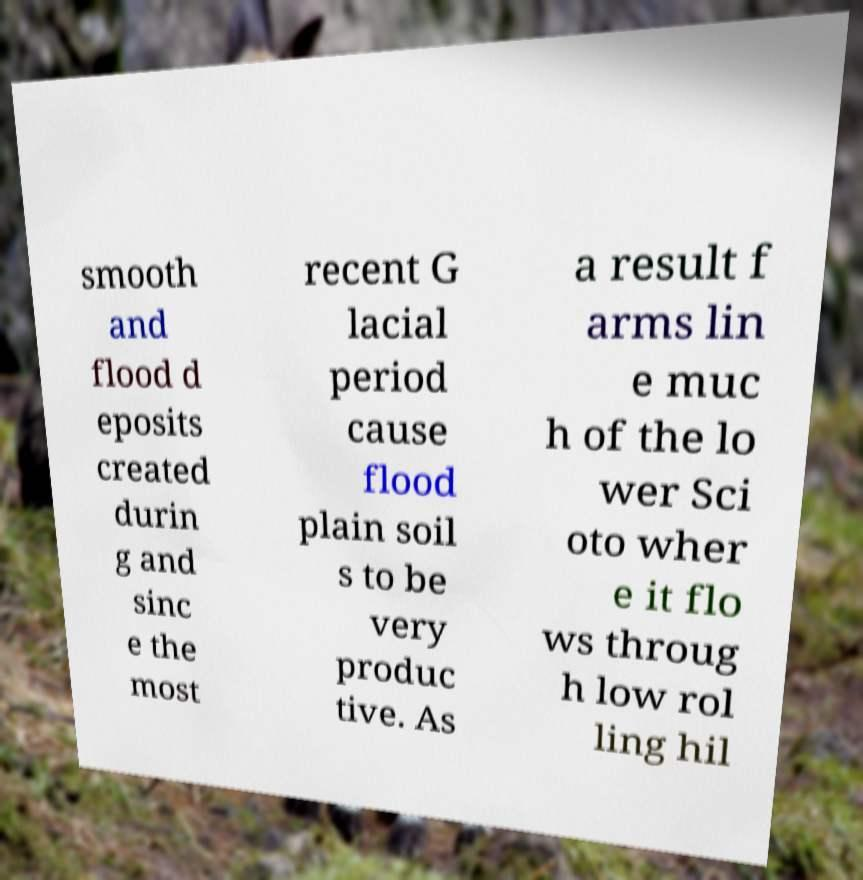Please identify and transcribe the text found in this image. smooth and flood d eposits created durin g and sinc e the most recent G lacial period cause flood plain soil s to be very produc tive. As a result f arms lin e muc h of the lo wer Sci oto wher e it flo ws throug h low rol ling hil 